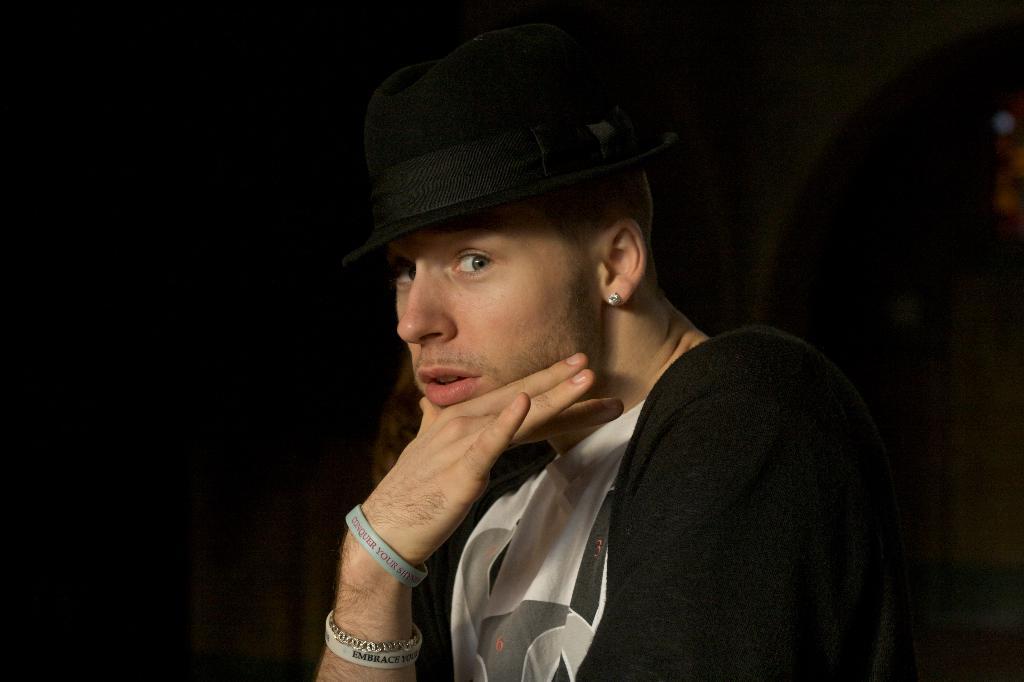How would you summarize this image in a sentence or two? In this picture we can see a person, he is wearing a cap and in the background we can see it is dark. 